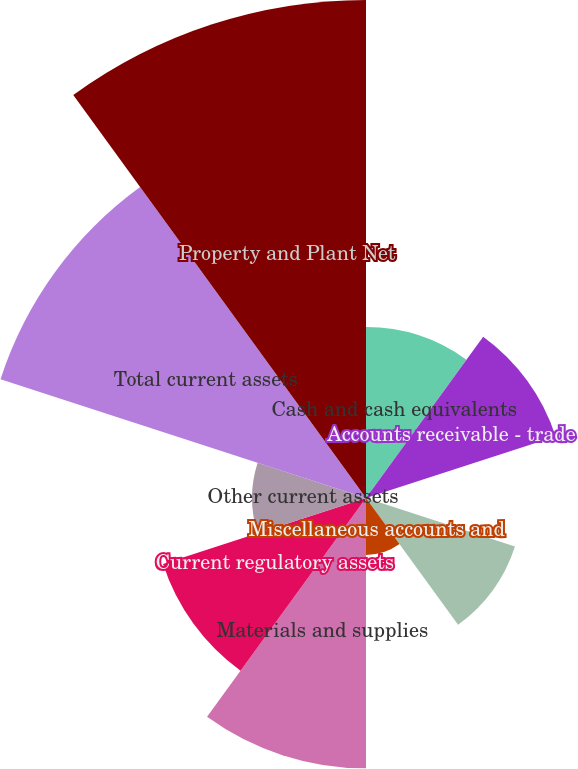Convert chart. <chart><loc_0><loc_0><loc_500><loc_500><pie_chart><fcel>Cash and cash equivalents<fcel>Accounts receivable - trade<fcel>Accounts receivable -<fcel>Unbilled revenue<fcel>Miscellaneous accounts and<fcel>Materials and supplies<fcel>Current regulatory assets<fcel>Other current assets<fcel>Total current assets<fcel>Property and Plant Net<nl><fcel>8.28%<fcel>9.66%<fcel>0.0%<fcel>7.59%<fcel>2.76%<fcel>13.1%<fcel>10.34%<fcel>5.52%<fcel>18.62%<fcel>24.13%<nl></chart> 